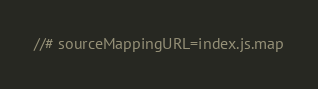<code> <loc_0><loc_0><loc_500><loc_500><_JavaScript_>//# sourceMappingURL=index.js.map</code> 